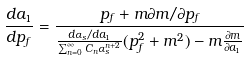<formula> <loc_0><loc_0><loc_500><loc_500>\frac { d a _ { 1 } } { d p _ { f } } = \frac { p _ { f } + m \partial m / \partial p _ { f } } { \frac { d \alpha _ { s } / d a _ { 1 } } { \sum _ { n = 0 } ^ { \infty } C _ { n } \alpha _ { s } ^ { n + 2 } } ( p _ { f } ^ { 2 } + m ^ { 2 } ) - m \frac { \partial m } { \partial a _ { 1 } } }</formula> 